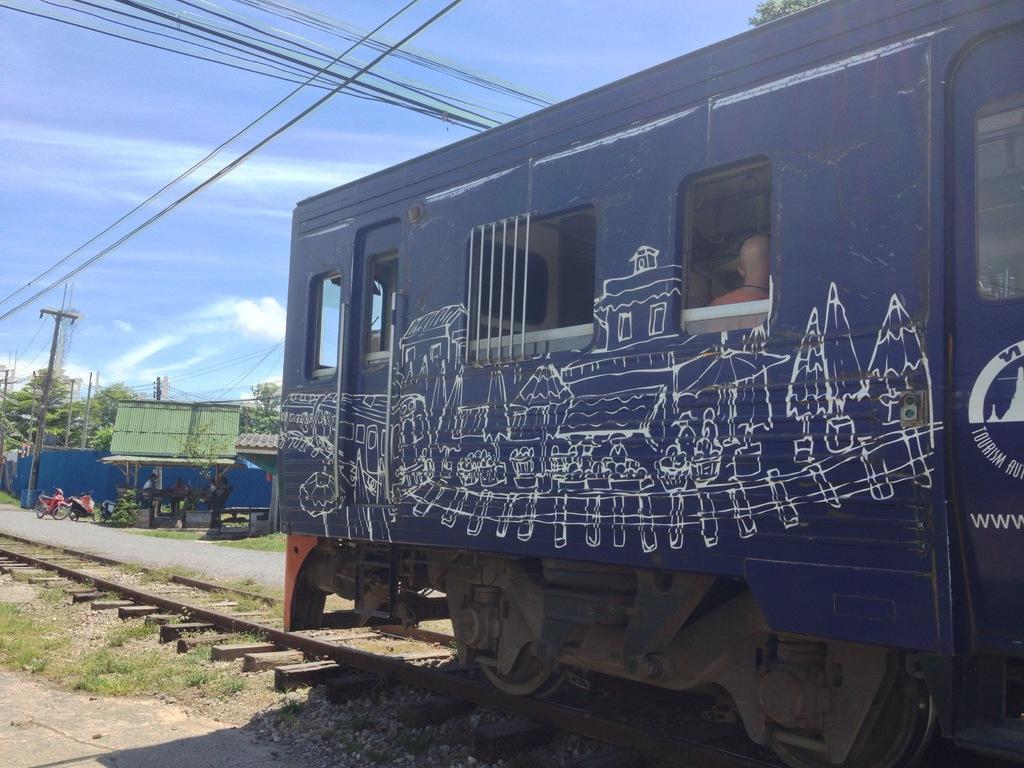In one or two sentences, can you explain what this image depicts? In this image, we can see a train on the track and we can see a person inside the train. In the background, there are sheds, trees, poles along with wires and we can see some people and there are vehicles on the road. At the top, there are clouds in the sky. 